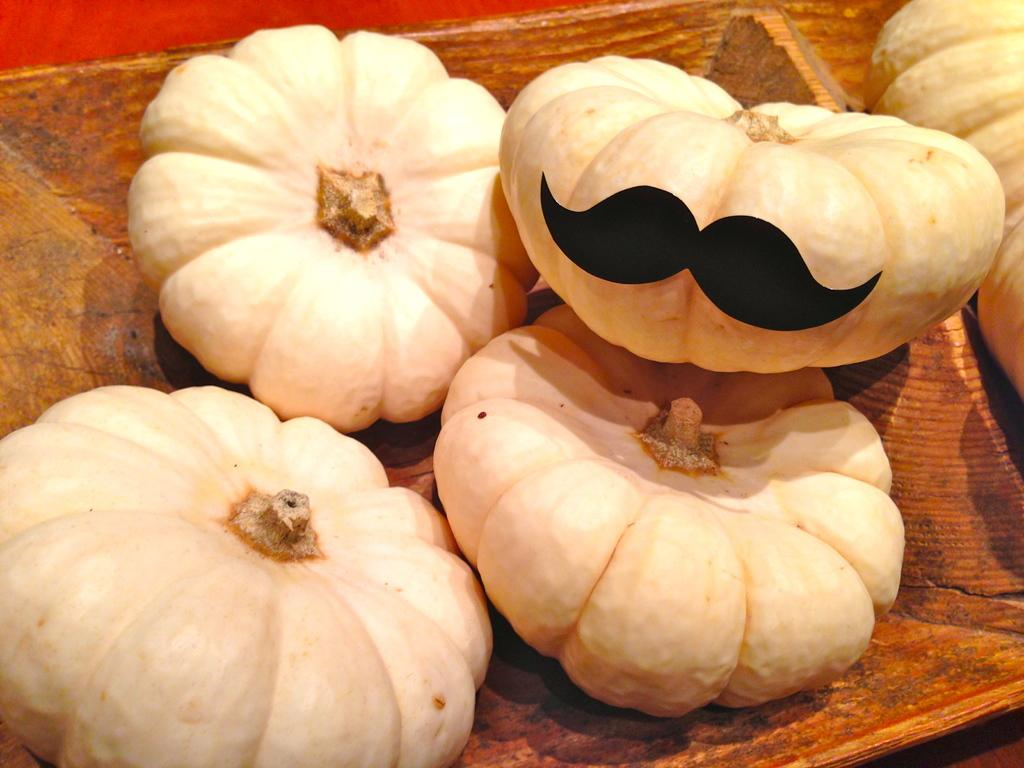What type of objects are in the image? There are pumpkins in the image. How are the pumpkins arranged or contained? The pumpkins are in a wooden basket. Where is the wooden basket with pumpkins located? The wooden basket with pumpkins is on the floor. Can you see any fairies interacting with the pumpkins in the image? There are no fairies present in the image. 